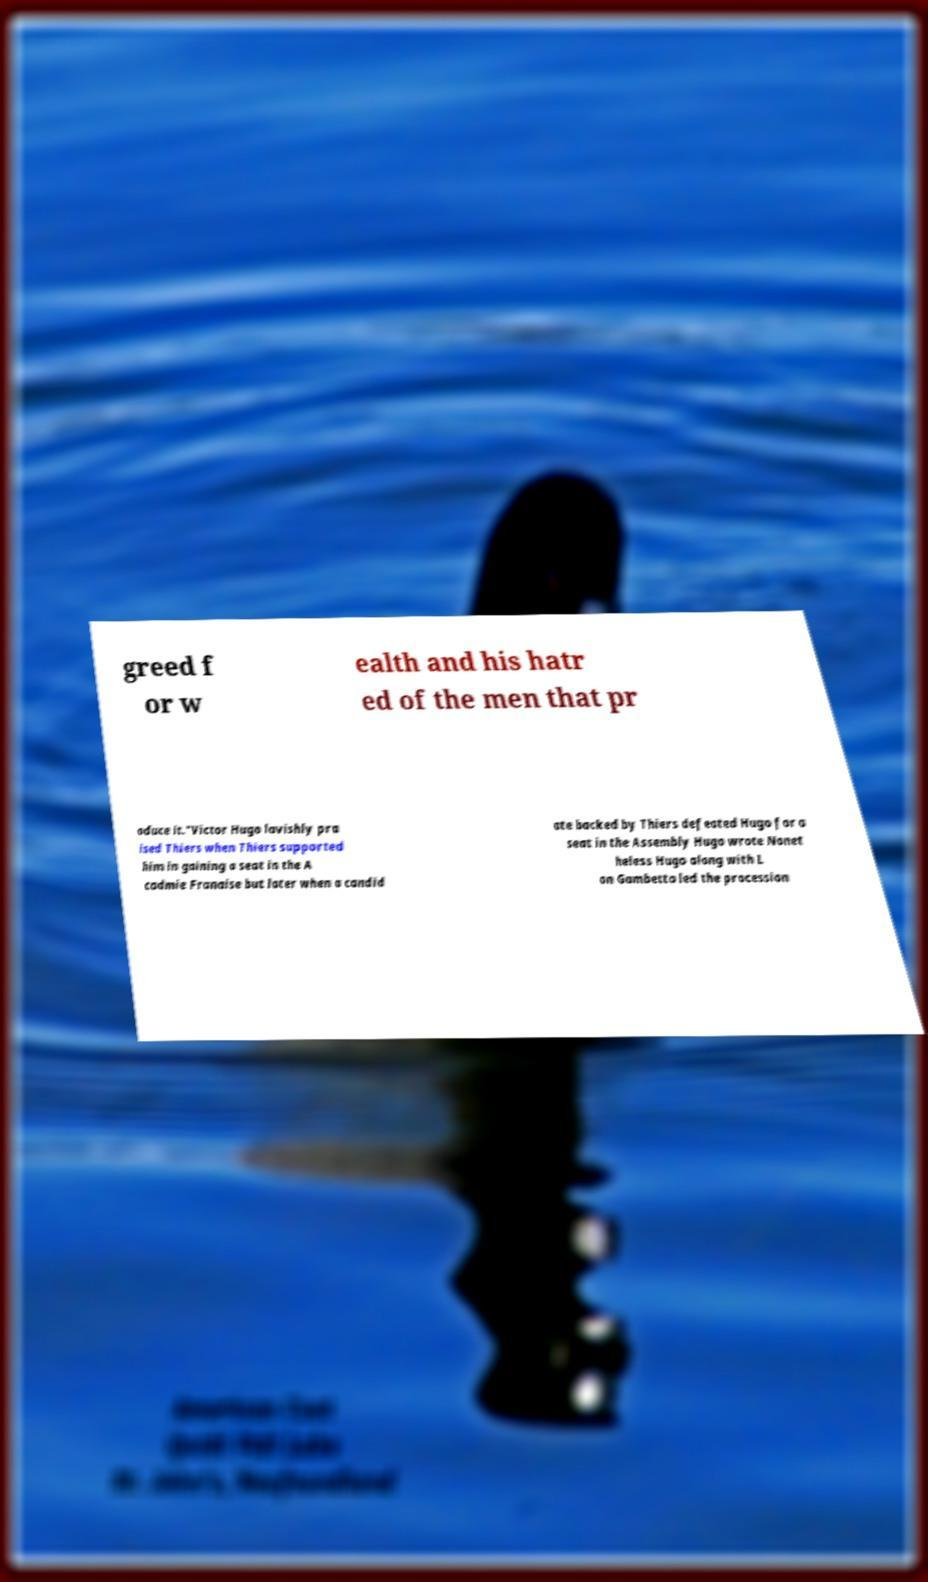For documentation purposes, I need the text within this image transcribed. Could you provide that? greed f or w ealth and his hatr ed of the men that pr oduce it."Victor Hugo lavishly pra ised Thiers when Thiers supported him in gaining a seat in the A cadmie Franaise but later when a candid ate backed by Thiers defeated Hugo for a seat in the Assembly Hugo wrote Nonet heless Hugo along with L on Gambetta led the procession 